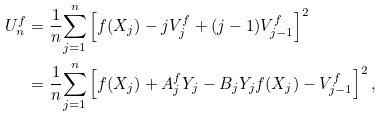Convert formula to latex. <formula><loc_0><loc_0><loc_500><loc_500>U _ { n } ^ { f } & = \frac { 1 } { n } { \sum _ { j = 1 } ^ { n } } \left [ f ( X _ { j } ) - j V ^ { f } _ { j } + ( j - 1 ) V ^ { f } _ { j - 1 } \right ] ^ { 2 } \\ & = \frac { 1 } { n } { \sum _ { j = 1 } ^ { n } } \left [ f ( X _ { j } ) + A ^ { f } _ { j } Y _ { j } - B _ { j } Y _ { j } f ( X _ { j } ) - V ^ { f } _ { j - 1 } \right ] ^ { 2 } ,</formula> 